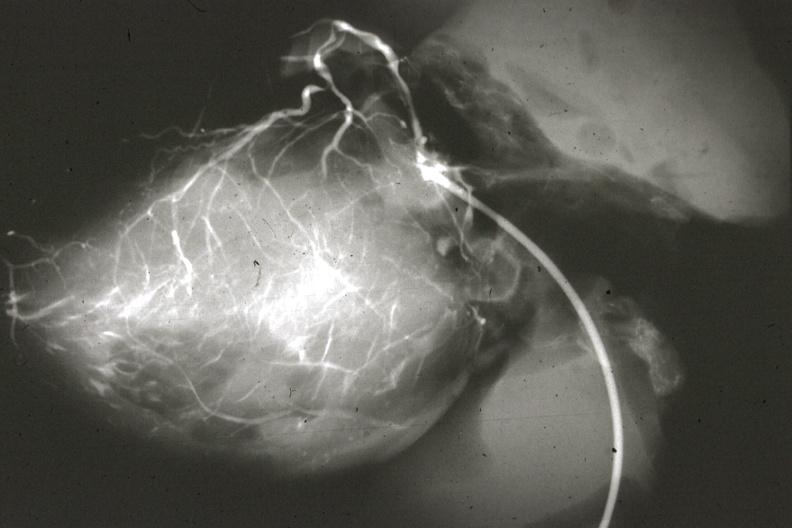what is present?
Answer the question using a single word or phrase. Cardiovascular 